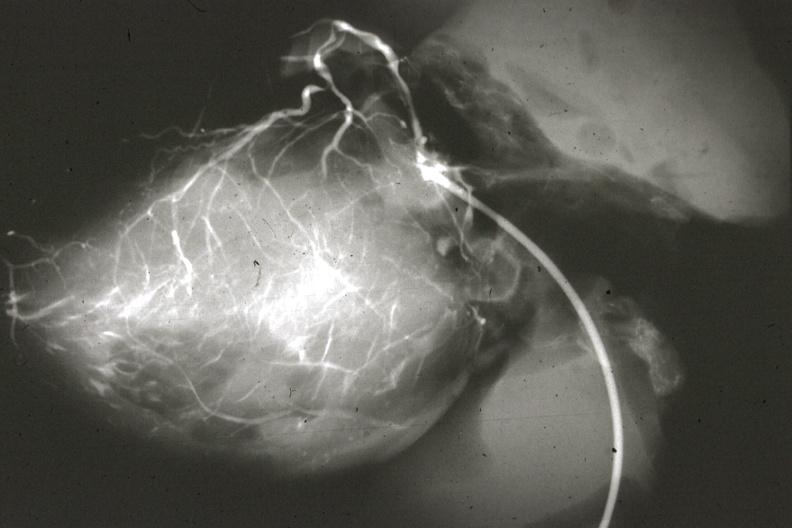what is present?
Answer the question using a single word or phrase. Cardiovascular 